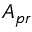<formula> <loc_0><loc_0><loc_500><loc_500>A _ { p r }</formula> 